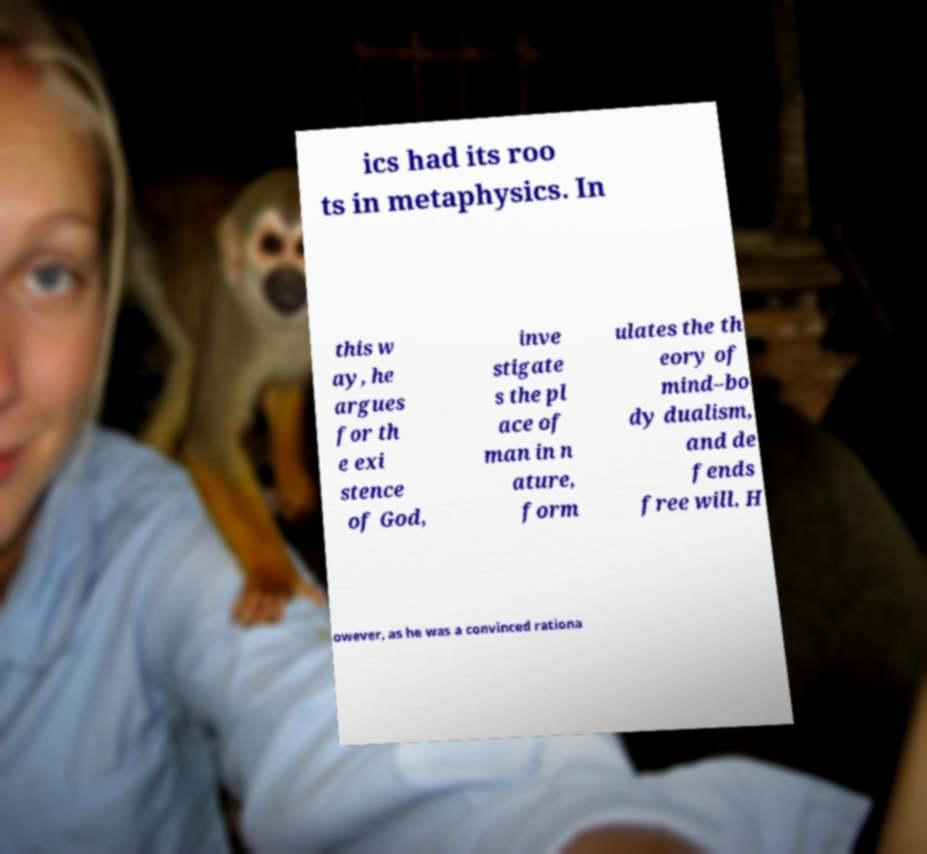Could you assist in decoding the text presented in this image and type it out clearly? ics had its roo ts in metaphysics. In this w ay, he argues for th e exi stence of God, inve stigate s the pl ace of man in n ature, form ulates the th eory of mind–bo dy dualism, and de fends free will. H owever, as he was a convinced rationa 